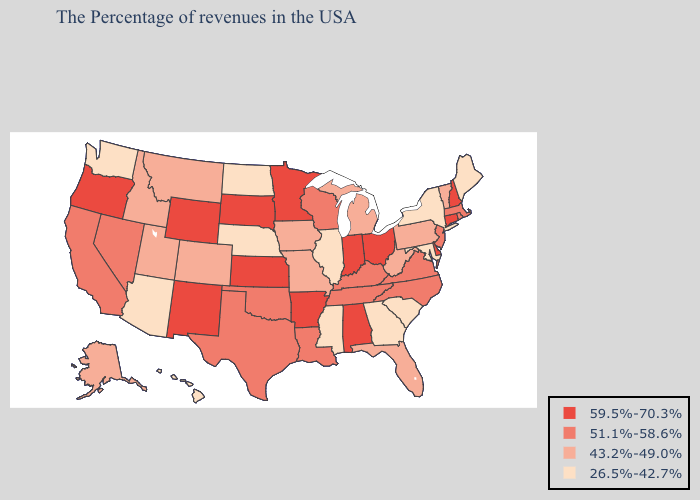Name the states that have a value in the range 59.5%-70.3%?
Give a very brief answer. New Hampshire, Connecticut, Delaware, Ohio, Indiana, Alabama, Arkansas, Minnesota, Kansas, South Dakota, Wyoming, New Mexico, Oregon. What is the lowest value in states that border Minnesota?
Quick response, please. 26.5%-42.7%. What is the value of Colorado?
Short answer required. 43.2%-49.0%. Name the states that have a value in the range 51.1%-58.6%?
Concise answer only. Massachusetts, Rhode Island, New Jersey, Virginia, North Carolina, Kentucky, Tennessee, Wisconsin, Louisiana, Oklahoma, Texas, Nevada, California. Is the legend a continuous bar?
Write a very short answer. No. What is the lowest value in the Northeast?
Short answer required. 26.5%-42.7%. Does Maryland have the highest value in the South?
Quick response, please. No. Does the map have missing data?
Keep it brief. No. Does Oklahoma have a higher value than Louisiana?
Keep it brief. No. Does Vermont have the lowest value in the Northeast?
Write a very short answer. No. Name the states that have a value in the range 43.2%-49.0%?
Be succinct. Vermont, Pennsylvania, West Virginia, Florida, Michigan, Missouri, Iowa, Colorado, Utah, Montana, Idaho, Alaska. What is the value of Minnesota?
Give a very brief answer. 59.5%-70.3%. How many symbols are there in the legend?
Write a very short answer. 4. Does New Hampshire have the highest value in the Northeast?
Be succinct. Yes. What is the lowest value in the USA?
Short answer required. 26.5%-42.7%. 